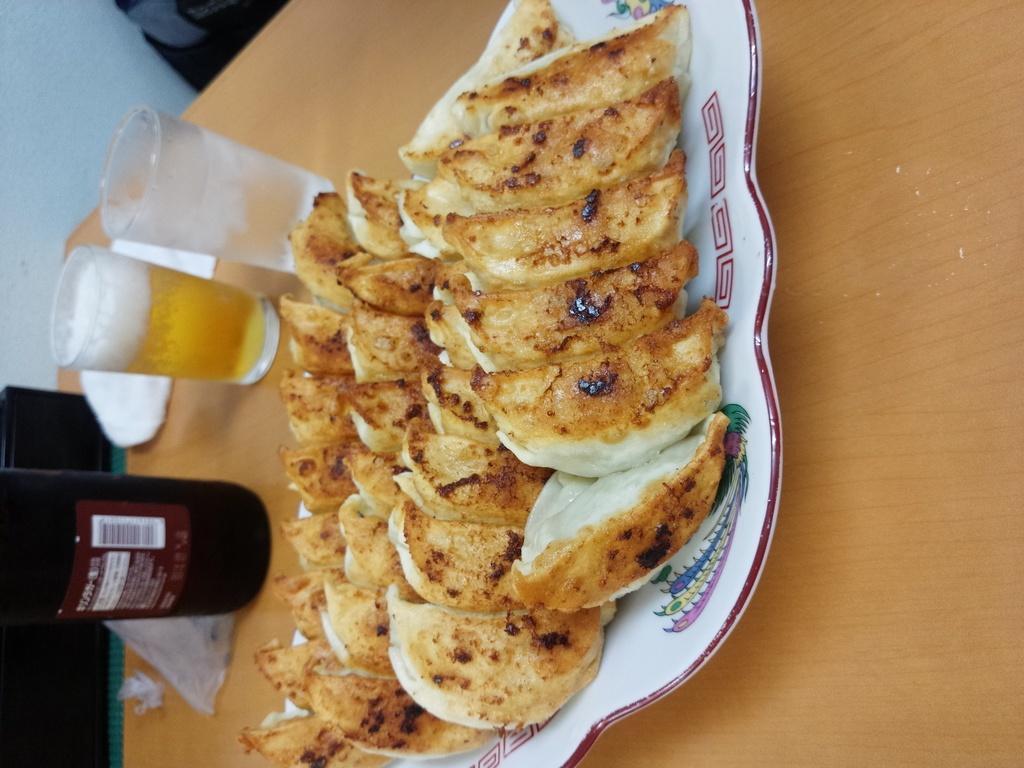How would you summarize this image in a sentence or two? In this image I can see a brown colored table and on it I can see two glasses with liquid in them, a black colored bottle with sticker attached to it, a white colored plate with few food items which are brown, cream and white in color. In the background I can see few white and black colored objects. 